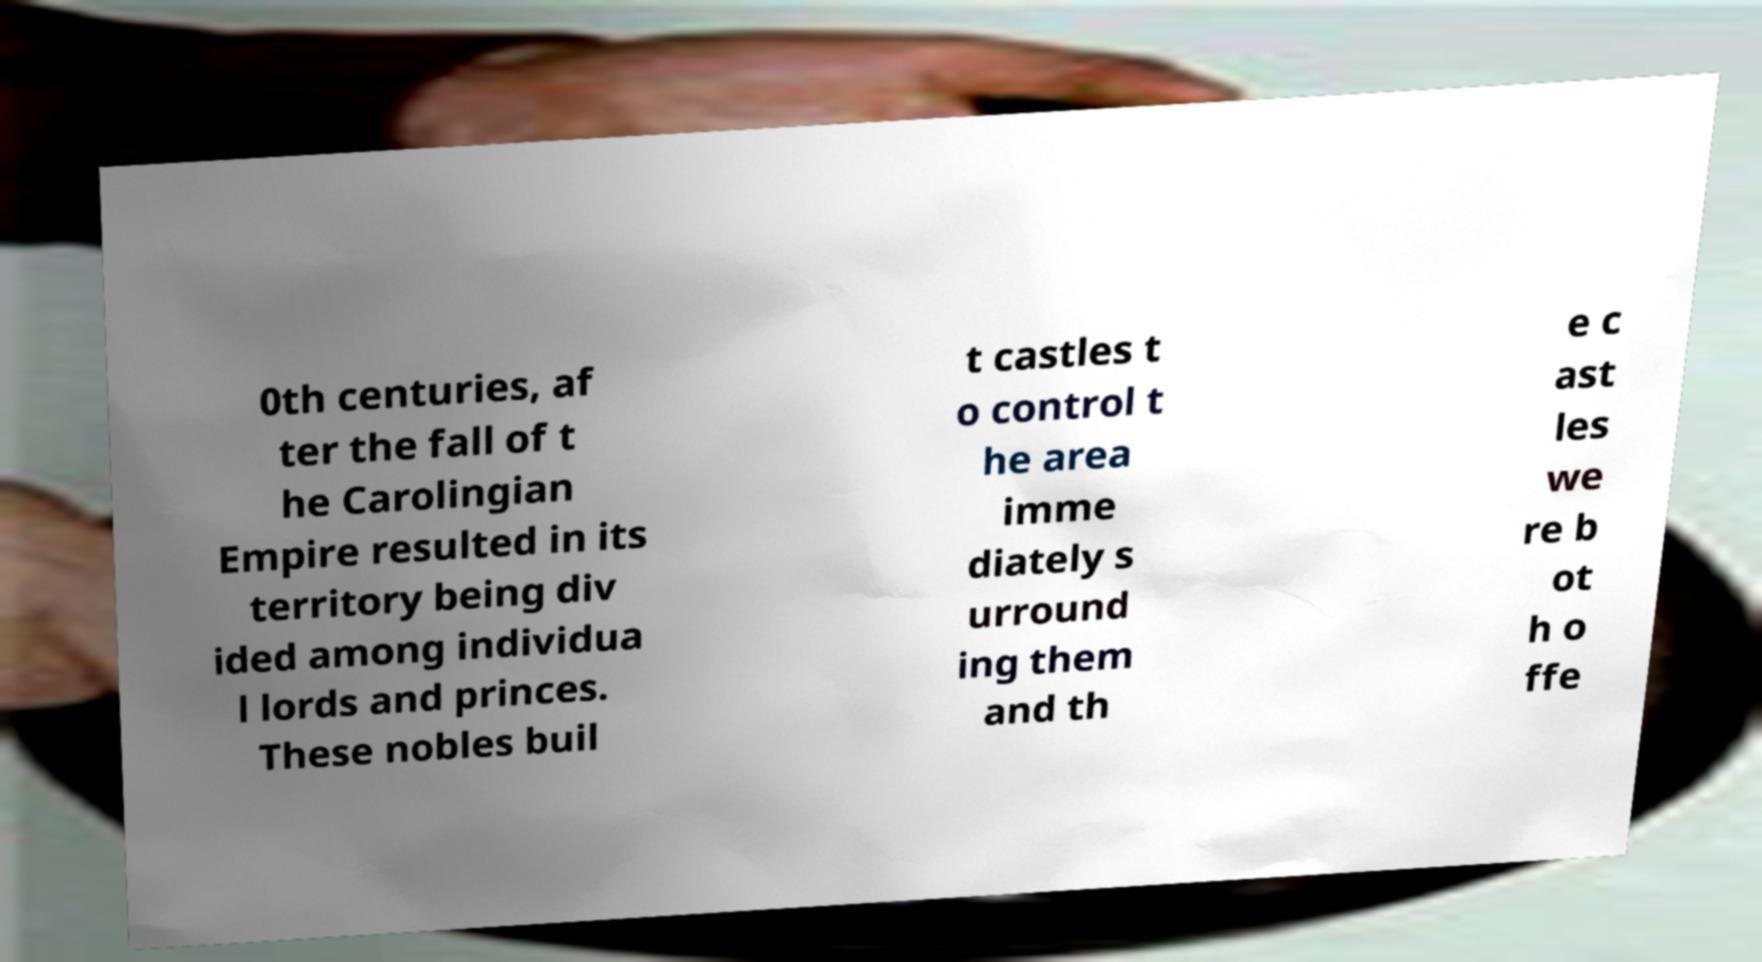Please read and relay the text visible in this image. What does it say? 0th centuries, af ter the fall of t he Carolingian Empire resulted in its territory being div ided among individua l lords and princes. These nobles buil t castles t o control t he area imme diately s urround ing them and th e c ast les we re b ot h o ffe 